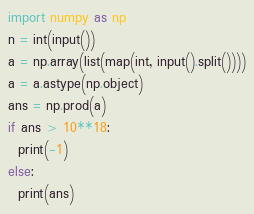Convert code to text. <code><loc_0><loc_0><loc_500><loc_500><_Python_>import numpy as np
n = int(input())
a = np.array(list(map(int, input().split())))
a = a.astype(np.object)
ans = np.prod(a)
if ans > 10**18:
  print(-1)
else:
  print(ans)</code> 